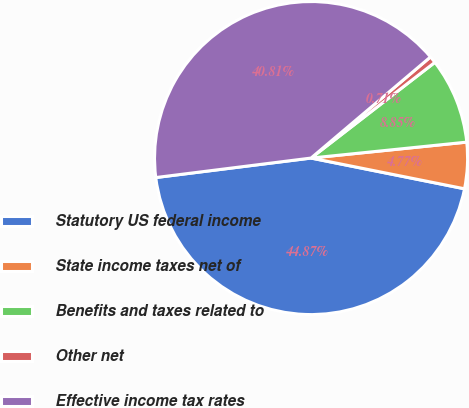<chart> <loc_0><loc_0><loc_500><loc_500><pie_chart><fcel>Statutory US federal income<fcel>State income taxes net of<fcel>Benefits and taxes related to<fcel>Other net<fcel>Effective income tax rates<nl><fcel>44.87%<fcel>4.77%<fcel>8.85%<fcel>0.71%<fcel>40.81%<nl></chart> 